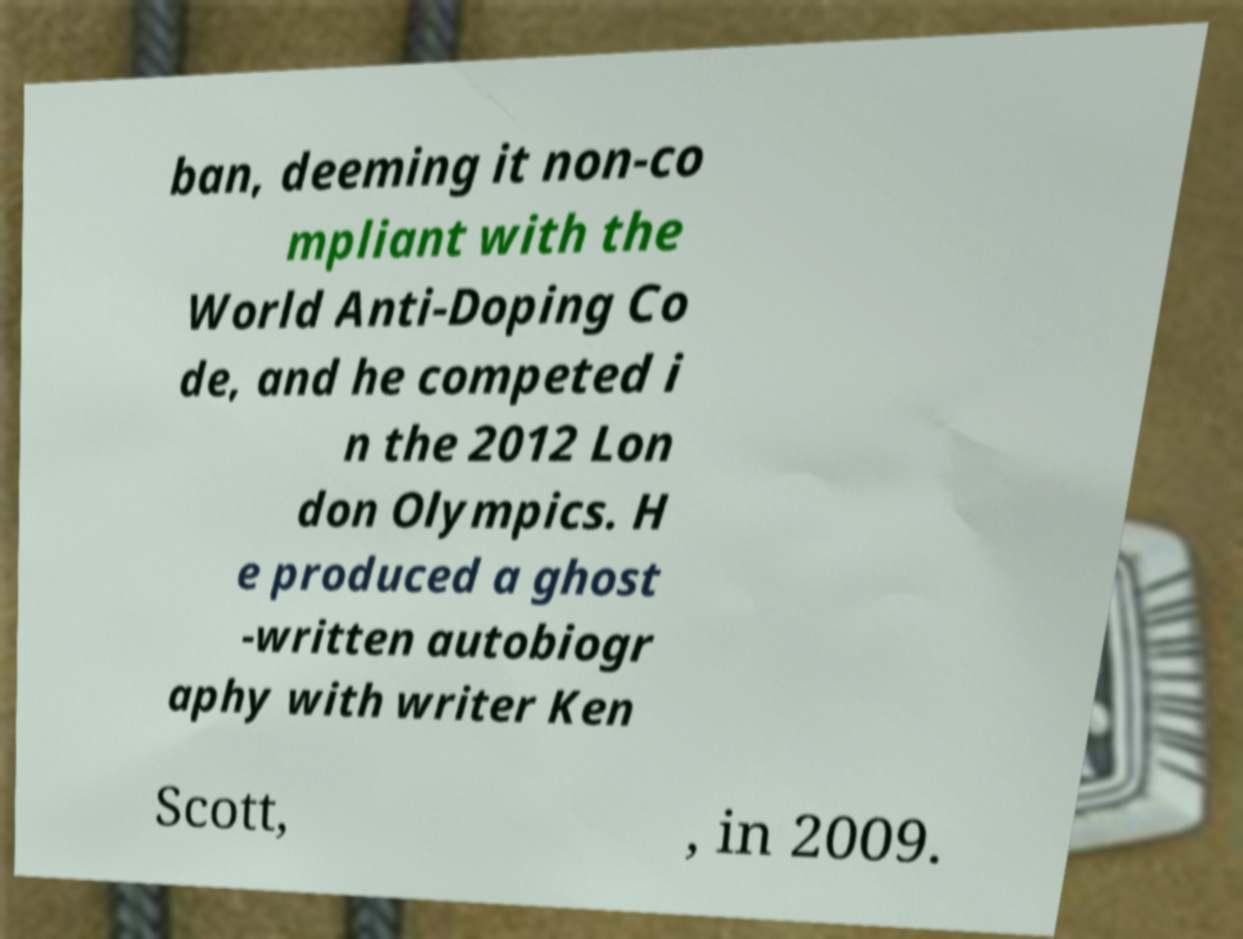Can you accurately transcribe the text from the provided image for me? ban, deeming it non-co mpliant with the World Anti-Doping Co de, and he competed i n the 2012 Lon don Olympics. H e produced a ghost -written autobiogr aphy with writer Ken Scott, , in 2009. 